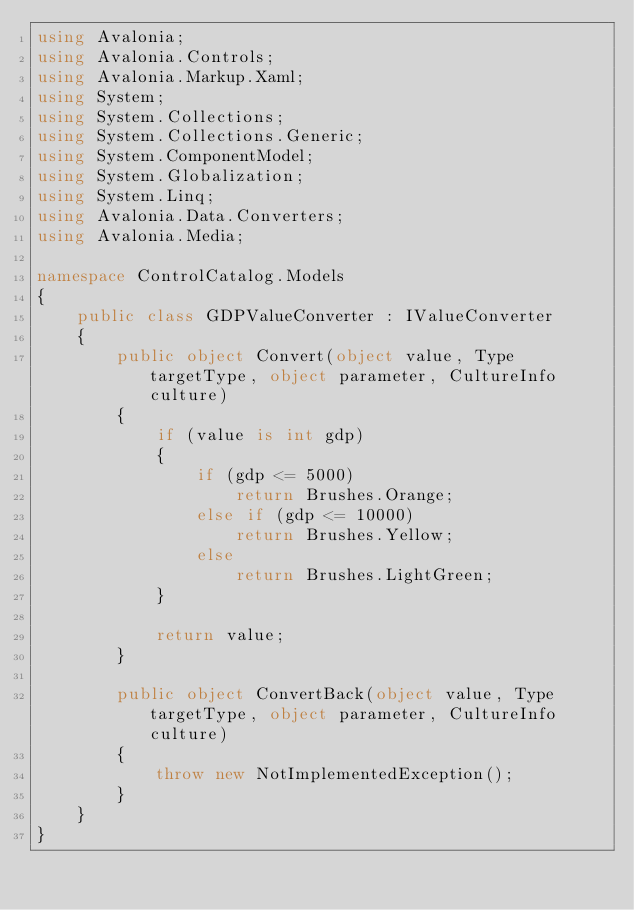Convert code to text. <code><loc_0><loc_0><loc_500><loc_500><_C#_>using Avalonia;
using Avalonia.Controls;
using Avalonia.Markup.Xaml;
using System;
using System.Collections;
using System.Collections.Generic;
using System.ComponentModel;
using System.Globalization;
using System.Linq;
using Avalonia.Data.Converters;
using Avalonia.Media;

namespace ControlCatalog.Models
{
    public class GDPValueConverter : IValueConverter
    {
        public object Convert(object value, Type targetType, object parameter, CultureInfo culture)
        {
            if (value is int gdp)
            {
                if (gdp <= 5000)
                    return Brushes.Orange;
                else if (gdp <= 10000)
                    return Brushes.Yellow;
                else
                    return Brushes.LightGreen;
            }

            return value;
        }

        public object ConvertBack(object value, Type targetType, object parameter, CultureInfo culture)
        {
            throw new NotImplementedException();
        }
    }
}</code> 